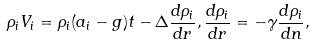Convert formula to latex. <formula><loc_0><loc_0><loc_500><loc_500>\rho _ { i } V _ { i } = \rho _ { i } ( a _ { i } - g ) t - \Delta \frac { d \rho _ { i } } { d r } , \frac { d \rho _ { i } } { d r } = - \gamma \frac { d \rho _ { i } } { d n } ,</formula> 